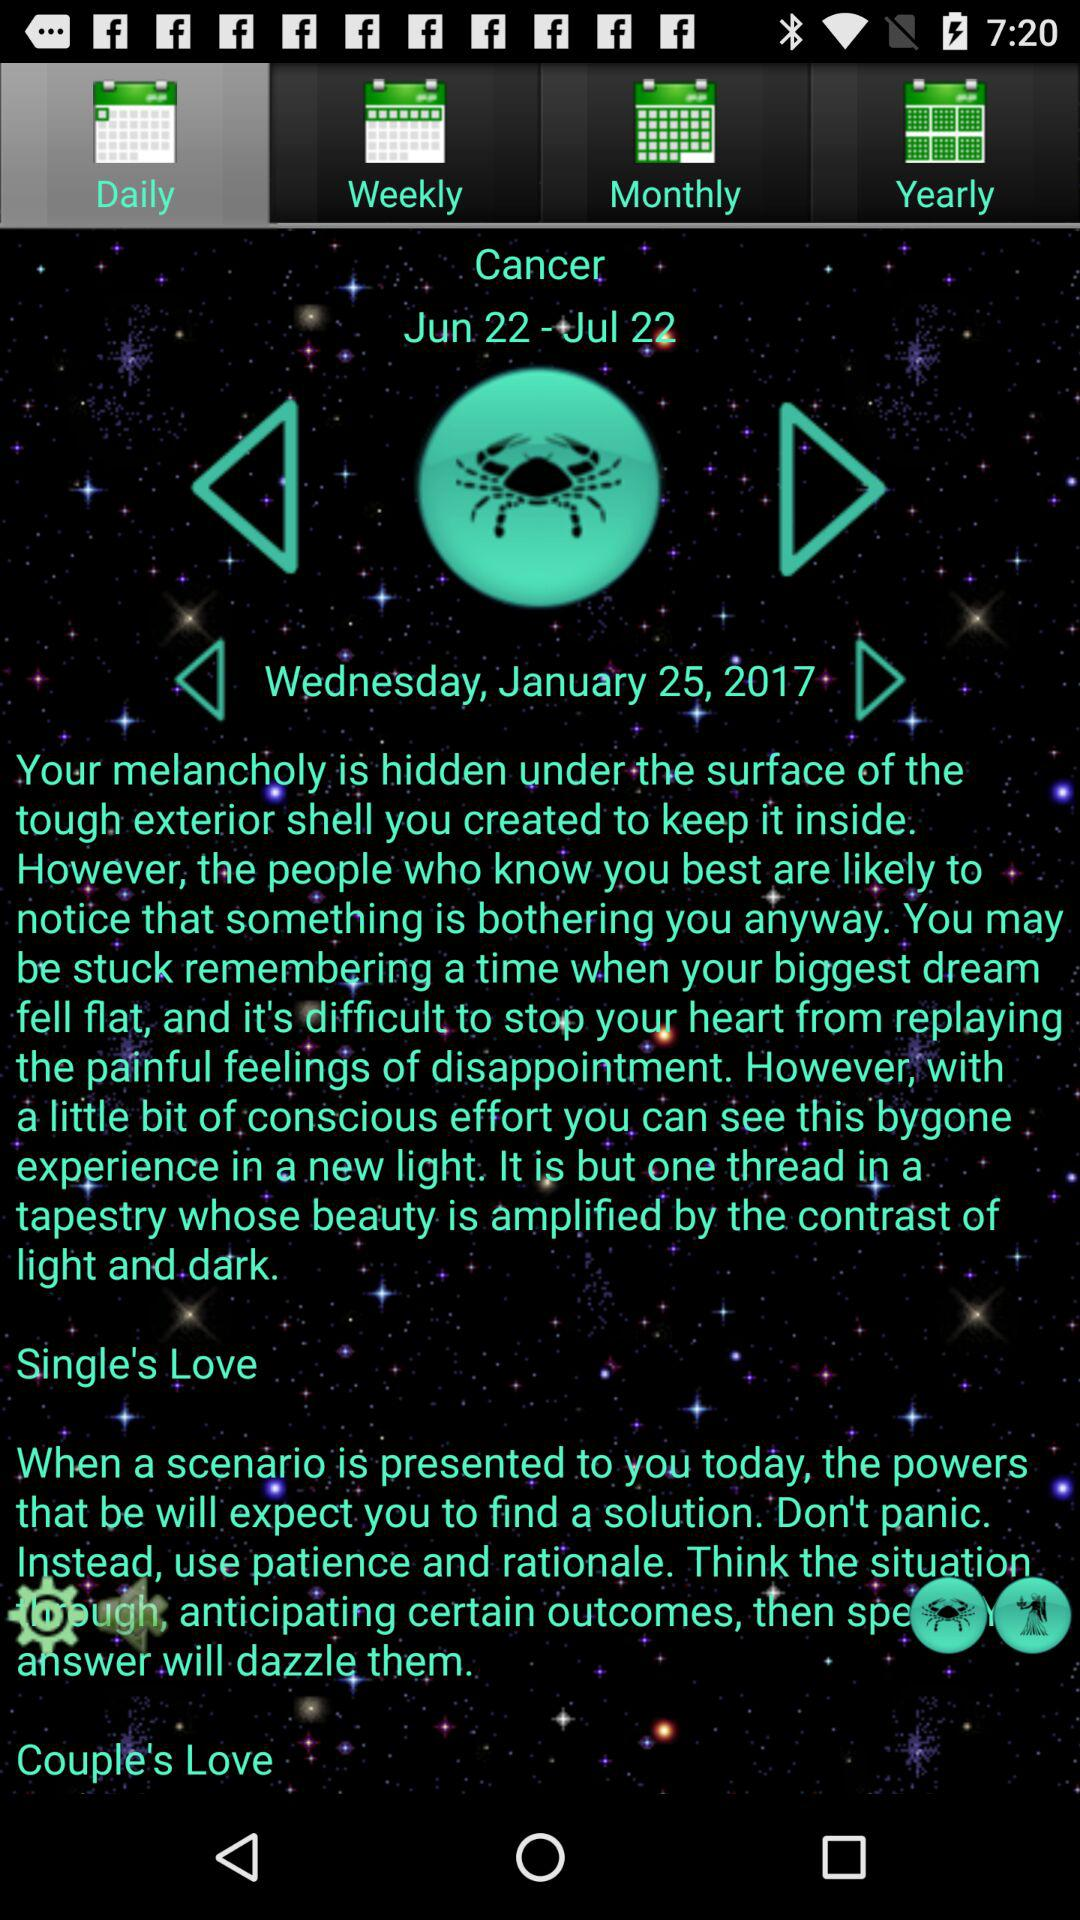What is the sun sign? The sun sign is "Cancer". 